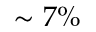Convert formula to latex. <formula><loc_0><loc_0><loc_500><loc_500>\sim 7 \%</formula> 